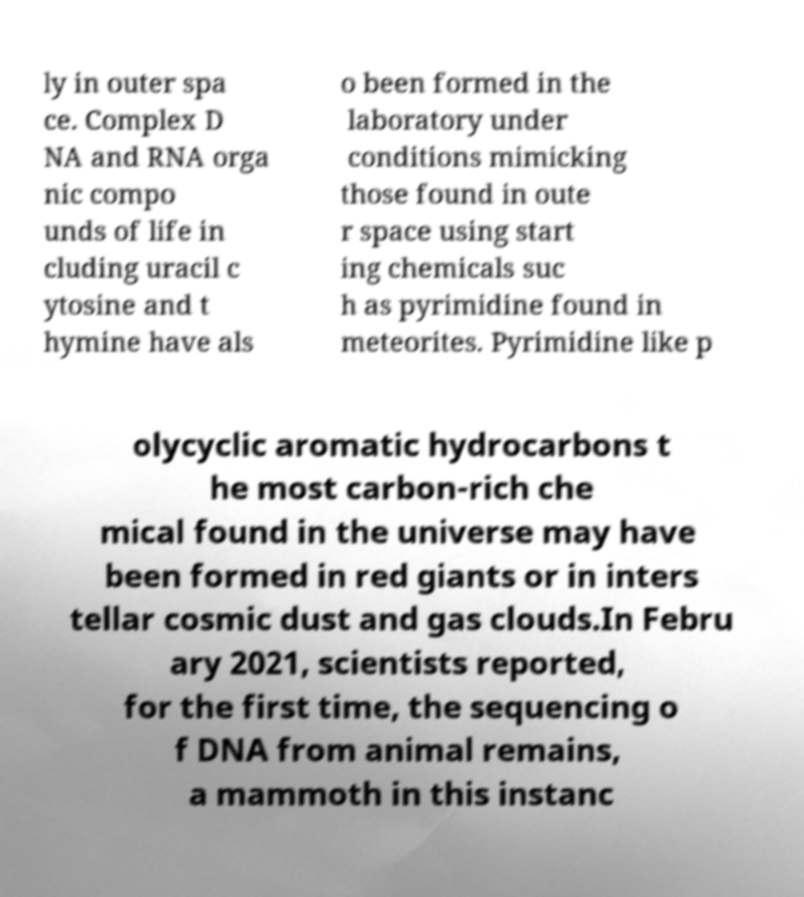I need the written content from this picture converted into text. Can you do that? ly in outer spa ce. Complex D NA and RNA orga nic compo unds of life in cluding uracil c ytosine and t hymine have als o been formed in the laboratory under conditions mimicking those found in oute r space using start ing chemicals suc h as pyrimidine found in meteorites. Pyrimidine like p olycyclic aromatic hydrocarbons t he most carbon-rich che mical found in the universe may have been formed in red giants or in inters tellar cosmic dust and gas clouds.In Febru ary 2021, scientists reported, for the first time, the sequencing o f DNA from animal remains, a mammoth in this instanc 